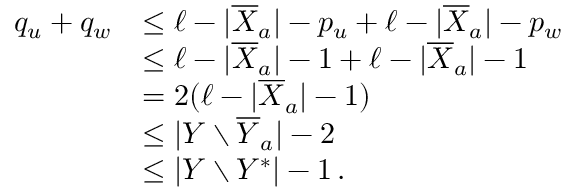<formula> <loc_0><loc_0><loc_500><loc_500>\begin{array} { r l } { q _ { u } + q _ { w } } & { \leq \ell - | \overline { X } _ { a } | - p _ { u } + \ell - | \overline { X } _ { a } | - p _ { w } } \\ & { \leq \ell - | \overline { X } _ { a } | - 1 + \ell - | \overline { X } _ { a } | - 1 } \\ & { = 2 ( \ell - | \overline { X } _ { a } | - 1 ) } \\ & { \leq | Y \ \overline { Y } _ { a } | - 2 } \\ & { \leq | Y \ Y ^ { * } | - 1 \, . } \end{array}</formula> 